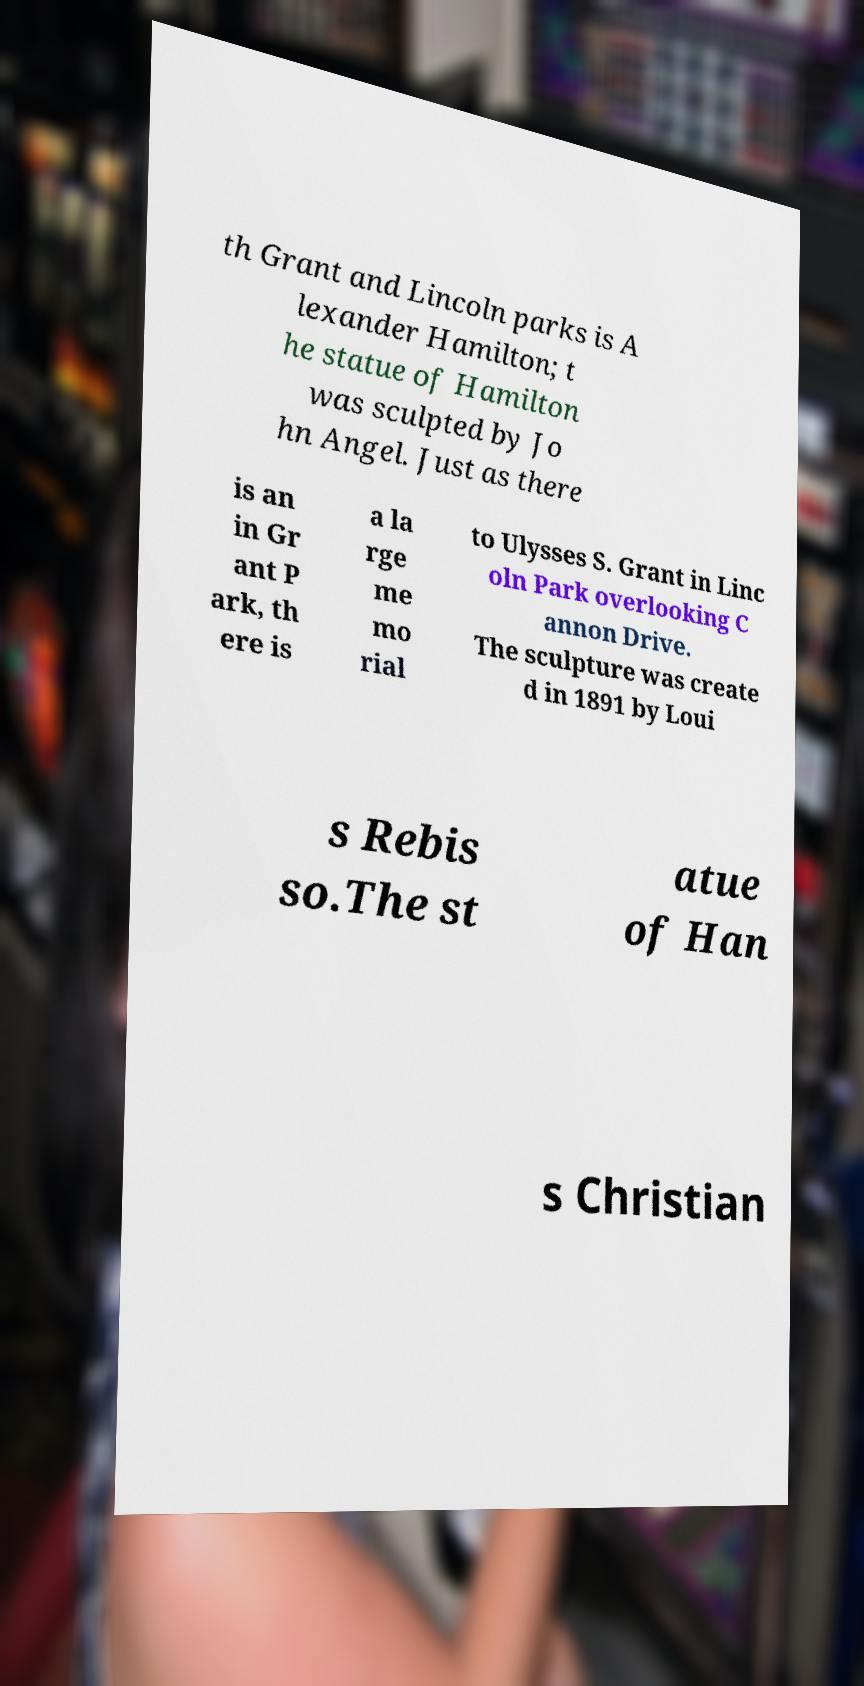For documentation purposes, I need the text within this image transcribed. Could you provide that? th Grant and Lincoln parks is A lexander Hamilton; t he statue of Hamilton was sculpted by Jo hn Angel. Just as there is an in Gr ant P ark, th ere is a la rge me mo rial to Ulysses S. Grant in Linc oln Park overlooking C annon Drive. The sculpture was create d in 1891 by Loui s Rebis so.The st atue of Han s Christian 